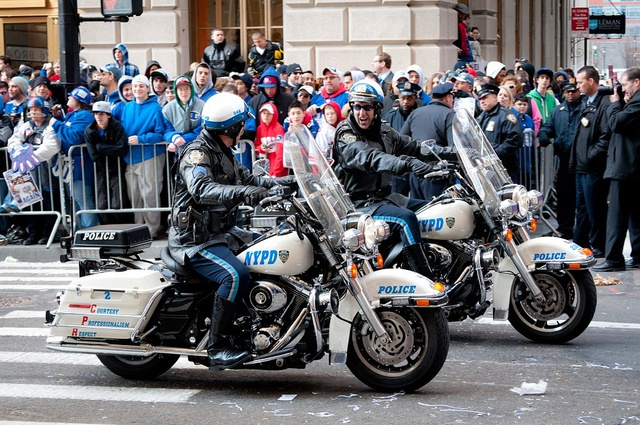Describe the objects in this image and their specific colors. I can see motorcycle in tan, black, lightgray, darkgray, and gray tones, people in tan, black, lightgray, darkgray, and gray tones, motorcycle in tan, black, darkgray, lightgray, and gray tones, people in tan, black, white, gray, and navy tones, and people in tan, black, gray, darkgray, and blue tones in this image. 